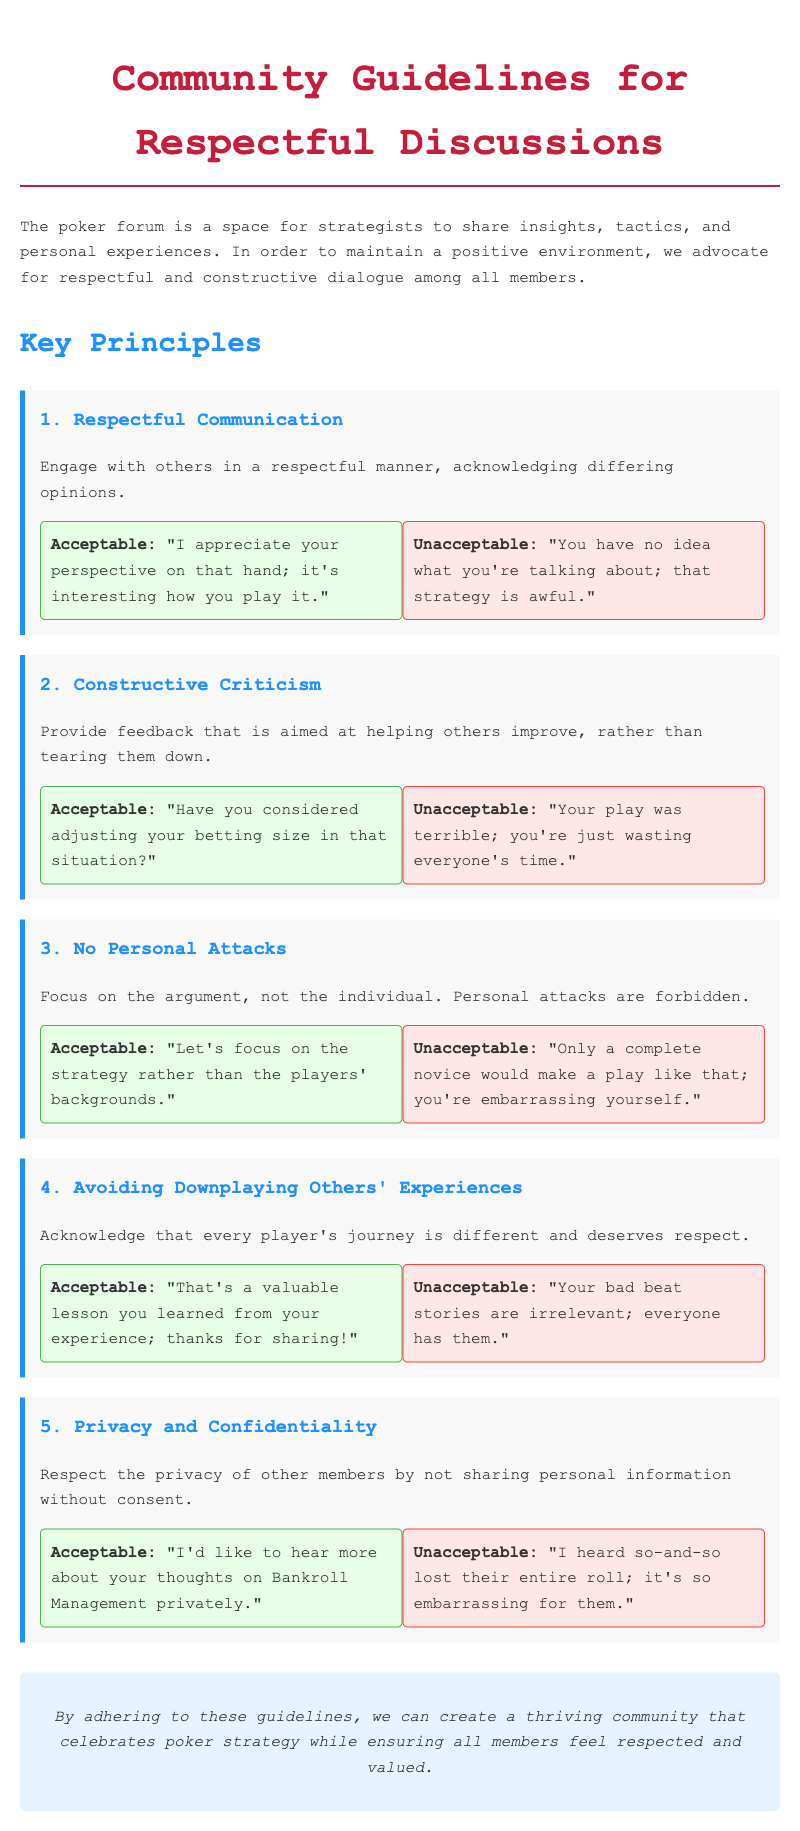What is the title of the document? The title is clearly stated at the beginning of the document, which is "Community Guidelines for Respectful Discussions."
Answer: Community Guidelines for Respectful Discussions How many key principles are outlined in the document? The document lists a total of five key principles for respectful discussions.
Answer: 5 What is an example of acceptable communication? The document provides an example under the principle of Respectful Communication: "I appreciate your perspective on that hand; it's interesting how you play it."
Answer: I appreciate your perspective on that hand; it's interesting how you play it What kind of comments are prohibited under the principle of No Personal Attacks? The document specifically mentions that personal attacks are forbidden, such as "Only a complete novice would make a play like that; you're embarrassing yourself."
Answer: Only a complete novice would make a play like that; you're embarrassing yourself What does the principle of Avoiding Downplaying Others' Experiences emphasize? The document highlights the importance of acknowledging that every player's journey is different and deserves respect.
Answer: Every player's journey is different and deserves respect 